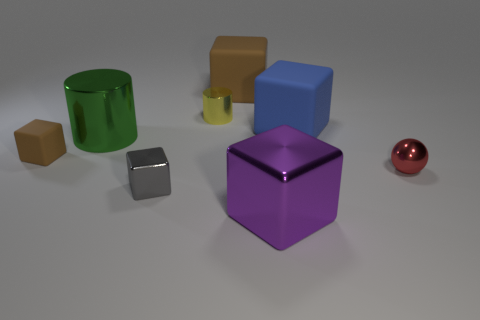Subtract 1 blocks. How many blocks are left? 4 Subtract all purple blocks. How many blocks are left? 4 Subtract all big blue rubber cubes. How many cubes are left? 4 Subtract all cyan cubes. Subtract all blue spheres. How many cubes are left? 5 Add 1 small objects. How many objects exist? 9 Subtract all cubes. How many objects are left? 3 Subtract 2 brown blocks. How many objects are left? 6 Subtract all matte blocks. Subtract all brown metallic balls. How many objects are left? 5 Add 5 red spheres. How many red spheres are left? 6 Add 5 yellow metallic cubes. How many yellow metallic cubes exist? 5 